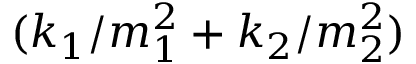Convert formula to latex. <formula><loc_0><loc_0><loc_500><loc_500>( k _ { 1 } / m _ { 1 } ^ { 2 } + k _ { 2 } / m _ { 2 } ^ { 2 } )</formula> 